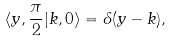Convert formula to latex. <formula><loc_0><loc_0><loc_500><loc_500>\langle y , \frac { \pi } { 2 } | k , 0 \rangle = \delta ( y - k ) ,</formula> 